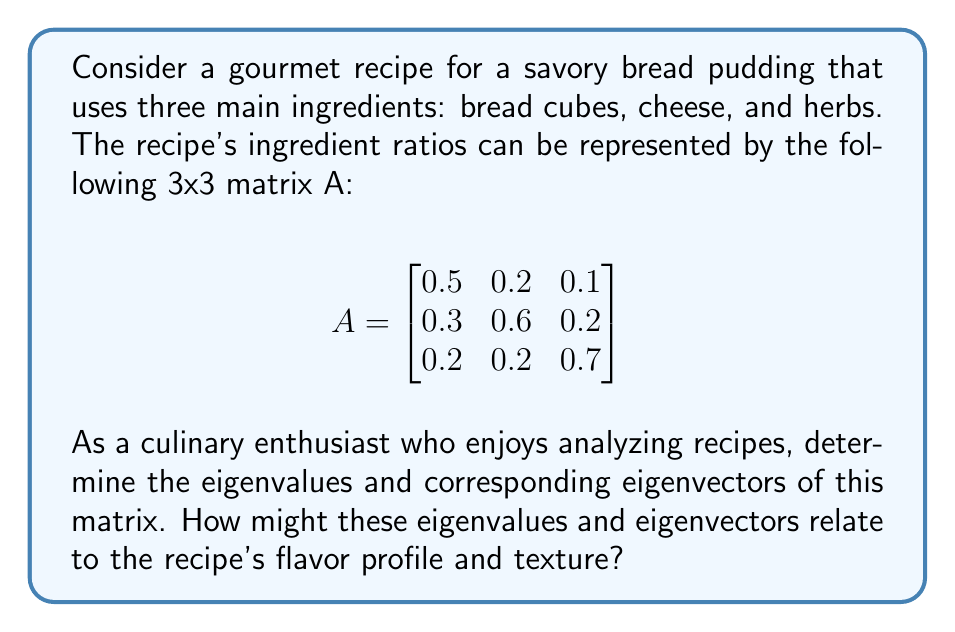Show me your answer to this math problem. To find the eigenvalues and eigenvectors of matrix A, we follow these steps:

1. Find the characteristic equation:
   $det(A - \lambda I) = 0$

   $$\begin{vmatrix}
   0.5 - \lambda & 0.2 & 0.1 \\
   0.3 & 0.6 - \lambda & 0.2 \\
   0.2 & 0.2 & 0.7 - \lambda
   \end{vmatrix} = 0$$

2. Expand the determinant:
   $(0.5 - \lambda)[(0.6 - \lambda)(0.7 - \lambda) - 0.04] - 0.2[0.3(0.7 - \lambda) - 0.06] + 0.1[0.3(0.2) - 0.2(0.6 - \lambda)] = 0$

3. Simplify:
   $-\lambda^3 + 1.8\lambda^2 - 0.83\lambda + 0.12 = 0$

4. Solve for $\lambda$ (eigenvalues):
   Using a polynomial solver or factoring, we get:
   $\lambda_1 \approx 1.0395$
   $\lambda_2 \approx 0.5302$
   $\lambda_3 \approx 0.2303$

5. Find eigenvectors for each eigenvalue:
   For each $\lambda_i$, solve $(A - \lambda_i I)\vec{v} = \vec{0}$

   For $\lambda_1 \approx 1.0395$:
   $$\begin{bmatrix}
   -0.5395 & 0.2 & 0.1 \\
   0.3 & -0.4395 & 0.2 \\
   0.2 & 0.2 & -0.3395
   \end{bmatrix}\vec{v_1} = \vec{0}$$

   Solving this system gives:
   $\vec{v_1} \approx (0.5774, 0.5774, 0.5774)$

   Similarly, for $\lambda_2$ and $\lambda_3$, we get:
   $\vec{v_2} \approx (-0.7071, 0, 0.7071)$
   $\vec{v_3} \approx (0.4082, -0.8165, 0.4082)$

Interpretation:
The largest eigenvalue (1.0395) corresponds to the dominant flavor profile, with its eigenvector suggesting a balanced mix of all ingredients. The second eigenvalue (0.5302) might represent a contrast between bread and herbs, while the third (0.2303) could indicate a subtle interplay between bread and cheese, with less herb influence.
Answer: Eigenvalues: $\lambda_1 \approx 1.0395$, $\lambda_2 \approx 0.5302$, $\lambda_3 \approx 0.2303$

Eigenvectors:
$\vec{v_1} \approx (0.5774, 0.5774, 0.5774)$
$\vec{v_2} \approx (-0.7071, 0, 0.7071)$
$\vec{v_3} \approx (0.4082, -0.8165, 0.4082)$ 